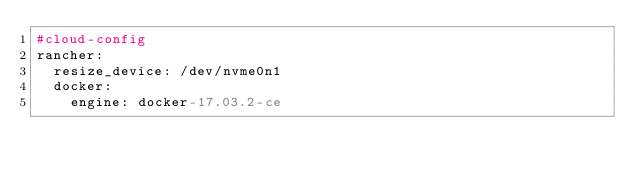<code> <loc_0><loc_0><loc_500><loc_500><_YAML_>#cloud-config
rancher:
  resize_device: /dev/nvme0n1
  docker:
    engine: docker-17.03.2-ce
</code> 